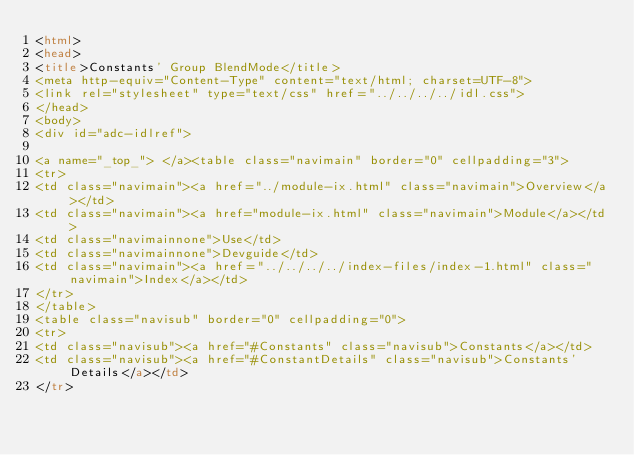Convert code to text. <code><loc_0><loc_0><loc_500><loc_500><_HTML_><html>
<head>
<title>Constants' Group BlendMode</title>
<meta http-equiv="Content-Type" content="text/html; charset=UTF-8">
<link rel="stylesheet" type="text/css" href="../../../../idl.css">
</head>
<body>
<div id="adc-idlref">

<a name="_top_"> </a><table class="navimain" border="0" cellpadding="3">
<tr>
<td class="navimain"><a href="../module-ix.html" class="navimain">Overview</a></td>
<td class="navimain"><a href="module-ix.html" class="navimain">Module</a></td>
<td class="navimainnone">Use</td>
<td class="navimainnone">Devguide</td>
<td class="navimain"><a href="../../../../index-files/index-1.html" class="navimain">Index</a></td>
</tr>
</table>
<table class="navisub" border="0" cellpadding="0">
<tr>
<td class="navisub"><a href="#Constants" class="navisub">Constants</a></td>
<td class="navisub"><a href="#ConstantDetails" class="navisub">Constants' Details</a></td>
</tr></code> 